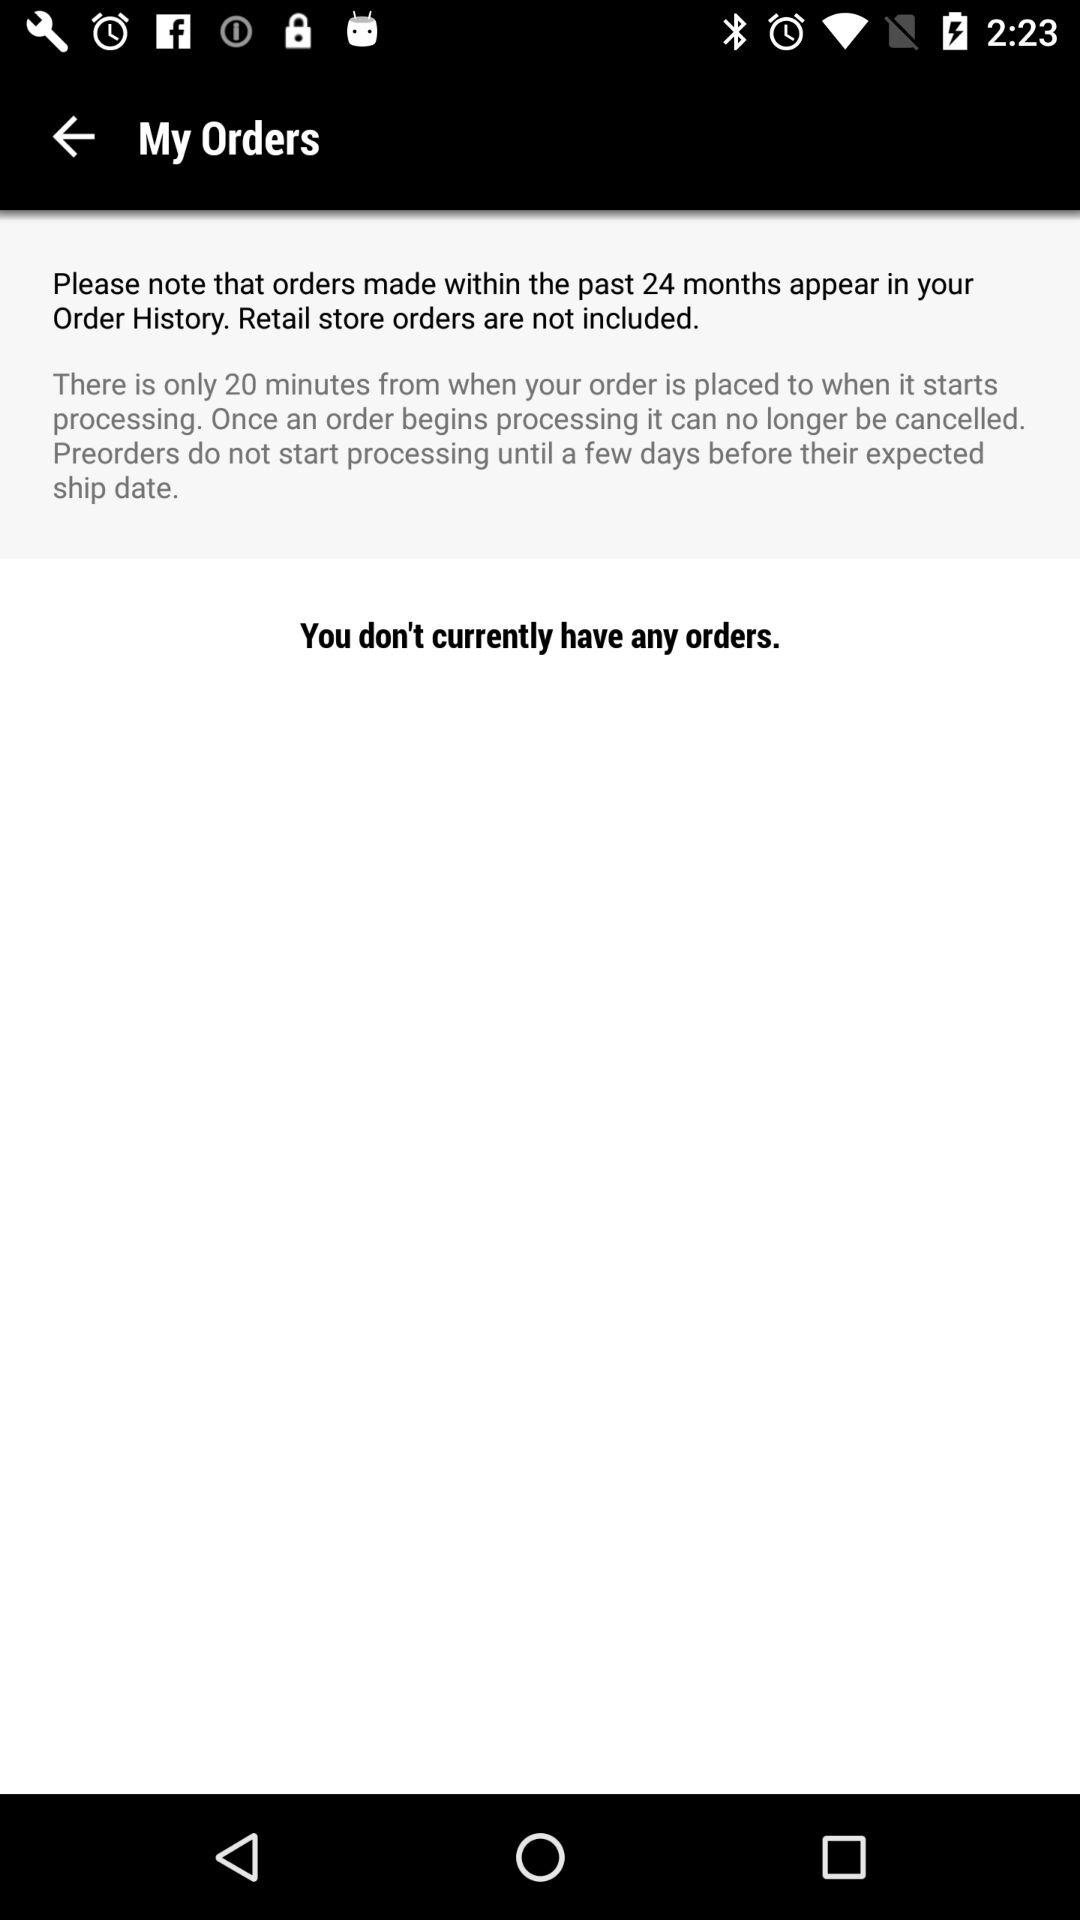What is the duration from when your order is placed to when it starts processing? The duration from when your order is placed to when it starts processing is 20 minutes. 